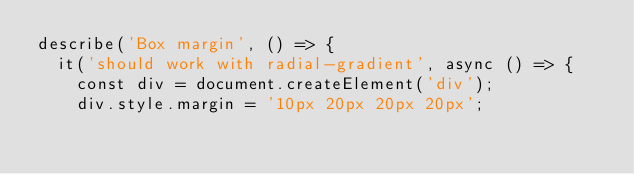Convert code to text. <code><loc_0><loc_0><loc_500><loc_500><_TypeScript_>describe('Box margin', () => {
  it('should work with radial-gradient', async () => {
    const div = document.createElement('div');
    div.style.margin = '10px 20px 20px 20px';</code> 